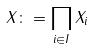Convert formula to latex. <formula><loc_0><loc_0><loc_500><loc_500>X \colon = \prod _ { i \in I } X _ { i }</formula> 